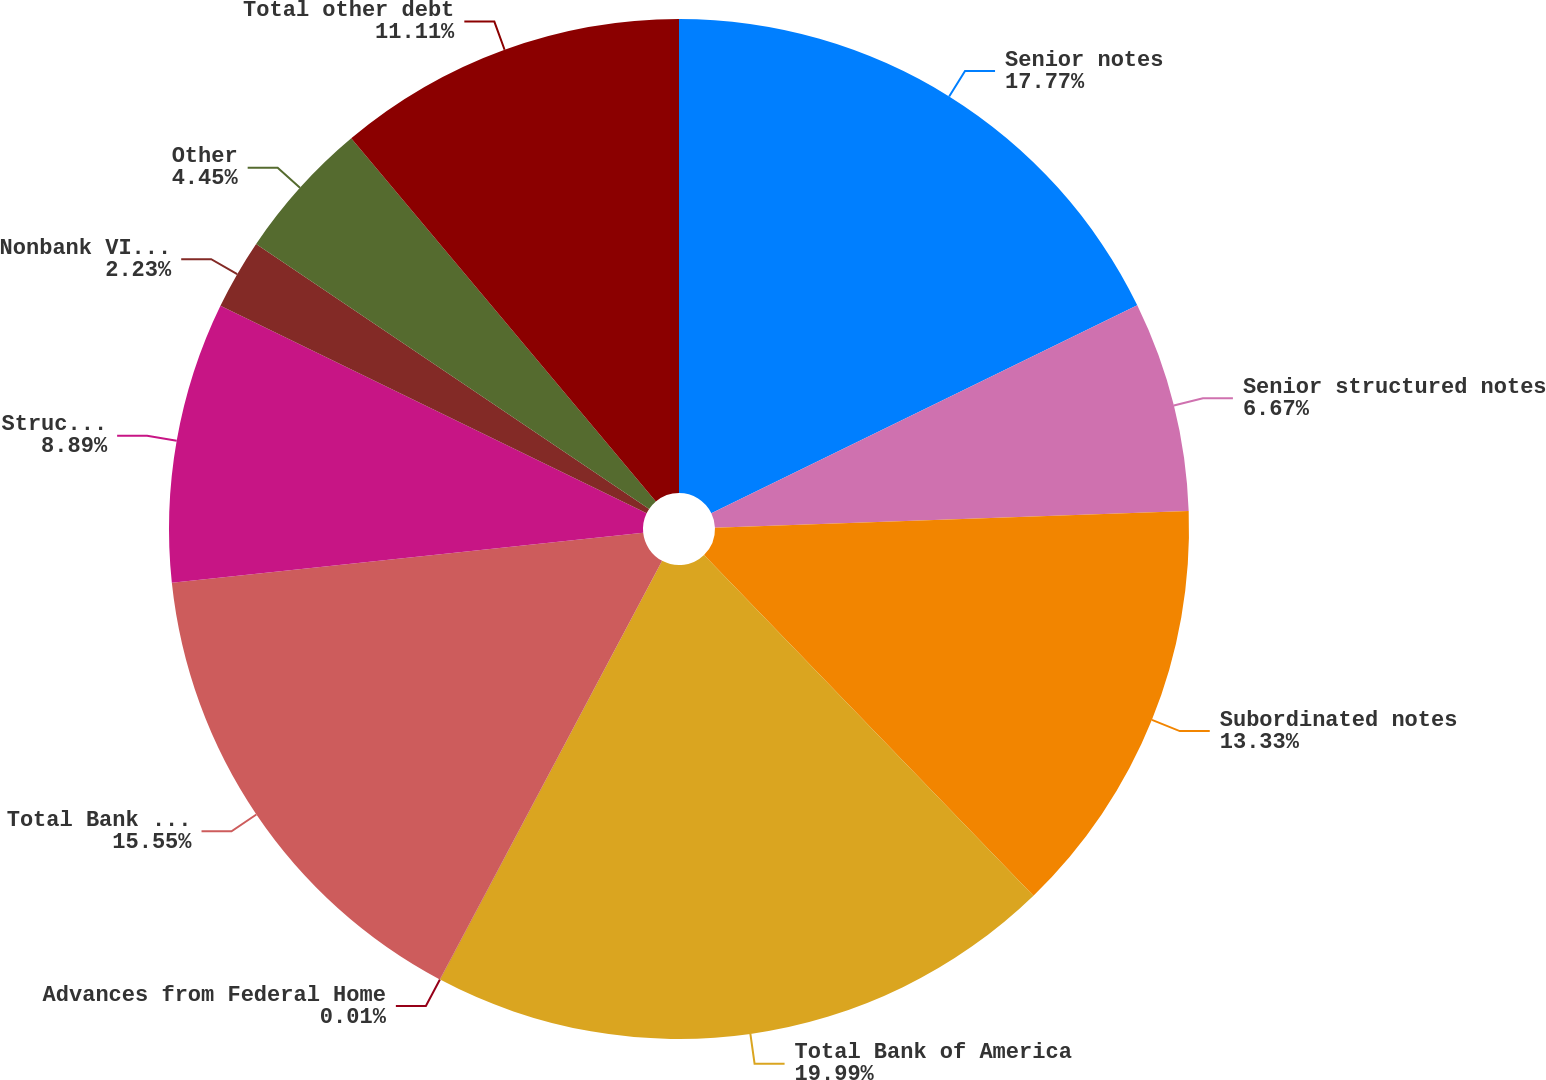<chart> <loc_0><loc_0><loc_500><loc_500><pie_chart><fcel>Senior notes<fcel>Senior structured notes<fcel>Subordinated notes<fcel>Total Bank of America<fcel>Advances from Federal Home<fcel>Total Bank of America NA<fcel>Structured liabilities<fcel>Nonbank VIEs (2)<fcel>Other<fcel>Total other debt<nl><fcel>17.77%<fcel>6.67%<fcel>13.33%<fcel>19.99%<fcel>0.01%<fcel>15.55%<fcel>8.89%<fcel>2.23%<fcel>4.45%<fcel>11.11%<nl></chart> 